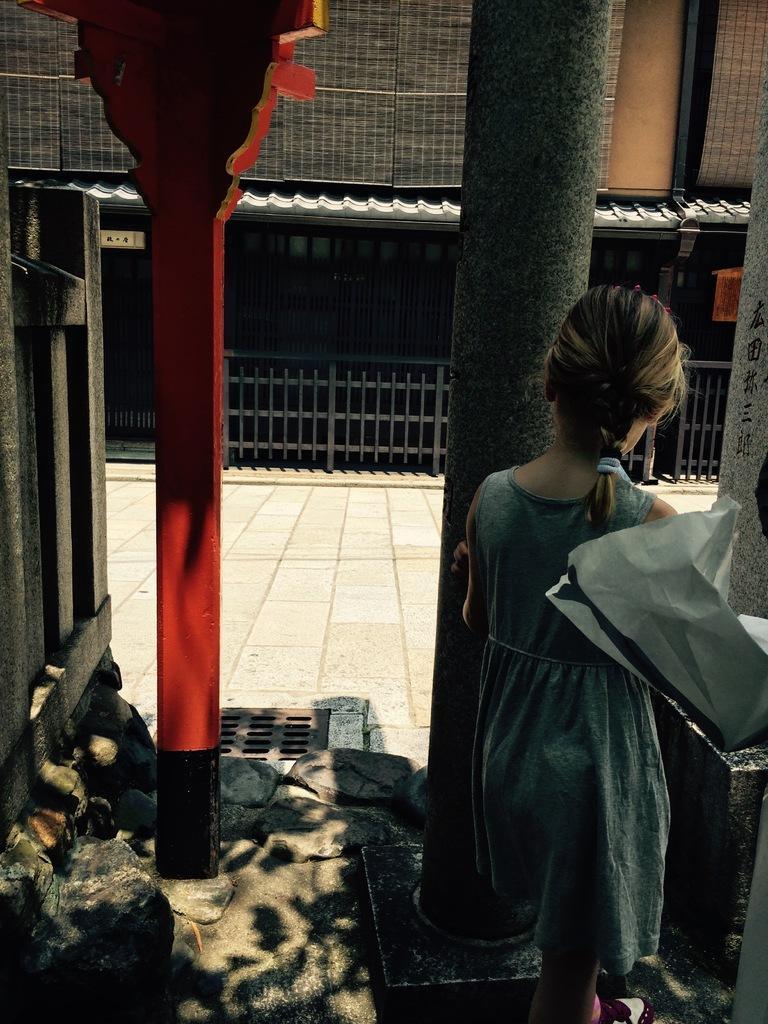How would you summarize this image in a sentence or two? In this picture I can see a girl standing near pillar, in front there is a house with some grilles. 